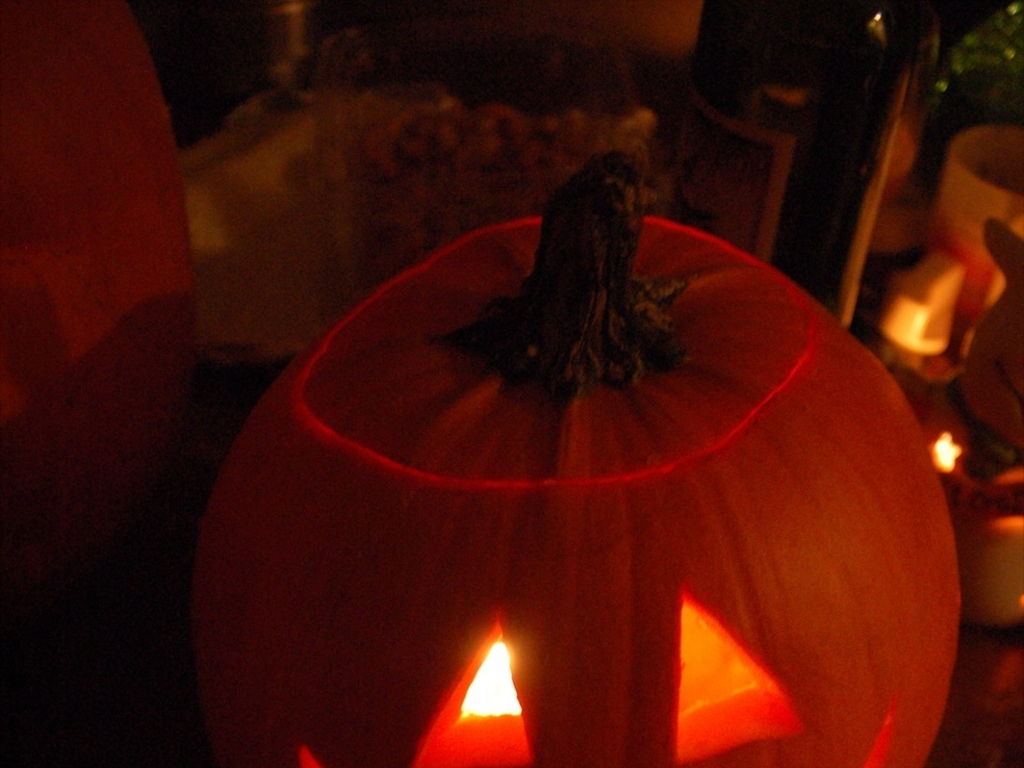What mood does the lighting of the pumpkin lantern create in the image? The warm, flickering light emanating from within the pumpkin lantern casts an inviting, yet slightly mysterious ambiance. It suggests a feeling of festivity typical of Halloween celebrations, while the shadows add a touch of spookiness and suspense. 